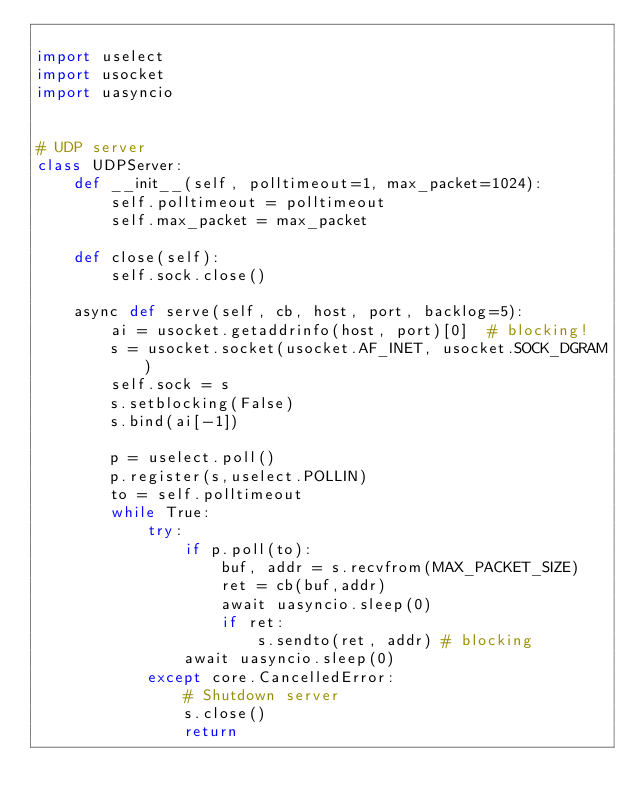<code> <loc_0><loc_0><loc_500><loc_500><_Python_>
import uselect
import usocket
import uasyncio


# UDP server
class UDPServer:
    def __init__(self, polltimeout=1, max_packet=1024):
        self.polltimeout = polltimeout
        self.max_packet = max_packet
    
    def close(self):
        self.sock.close()

    async def serve(self, cb, host, port, backlog=5):
        ai = usocket.getaddrinfo(host, port)[0]  # blocking!
        s = usocket.socket(usocket.AF_INET, usocket.SOCK_DGRAM)
        self.sock = s
        s.setblocking(False)
        s.bind(ai[-1])

        p = uselect.poll()
        p.register(s,uselect.POLLIN)
        to = self.polltimeout
        while True:
            try:
                if p.poll(to):
                    buf, addr = s.recvfrom(MAX_PACKET_SIZE)
                    ret = cb(buf,addr)
                    await uasyncio.sleep(0)
                    if ret:
                        s.sendto(ret, addr) # blocking
                await uasyncio.sleep(0)
            except core.CancelledError:
                # Shutdown server
                s.close()
                return

            

</code> 